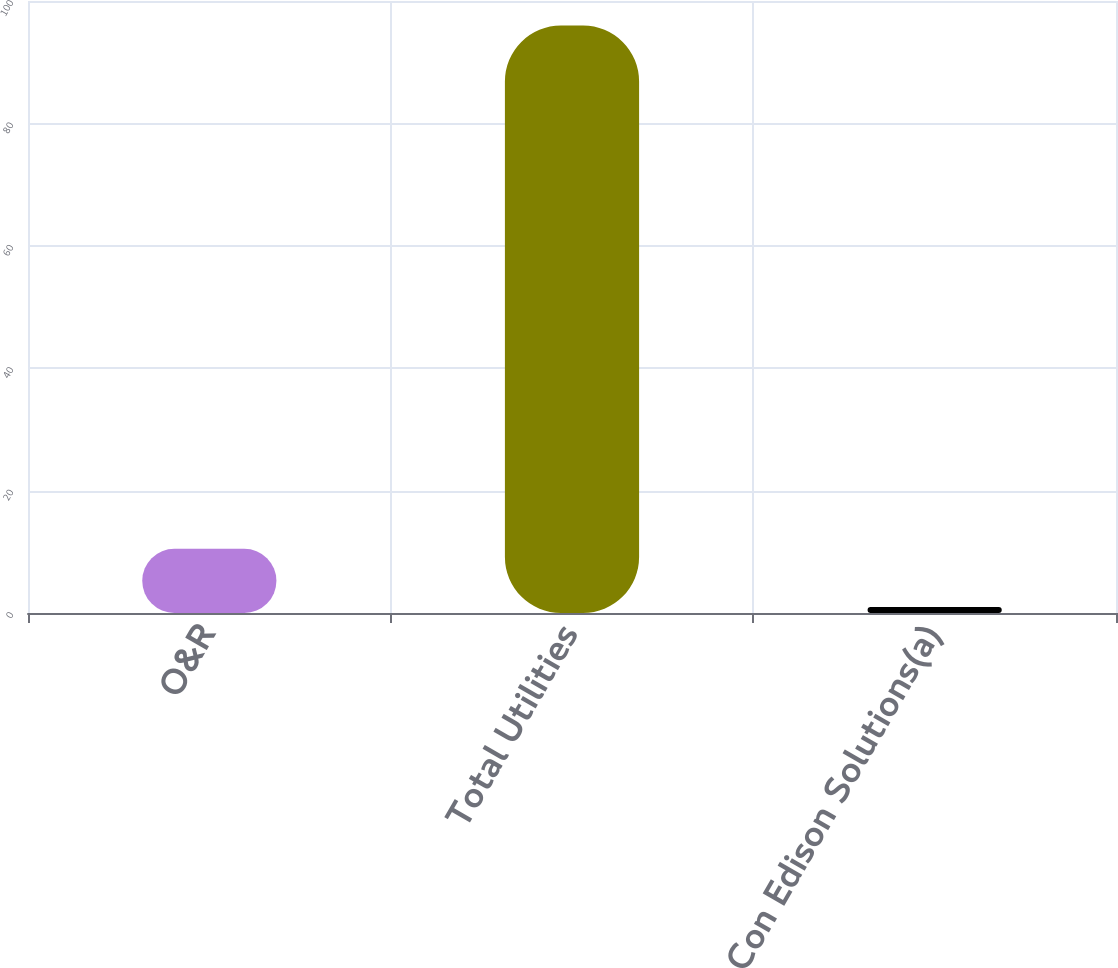Convert chart to OTSL. <chart><loc_0><loc_0><loc_500><loc_500><bar_chart><fcel>O&R<fcel>Total Utilities<fcel>Con Edison Solutions(a)<nl><fcel>10.5<fcel>96<fcel>1<nl></chart> 